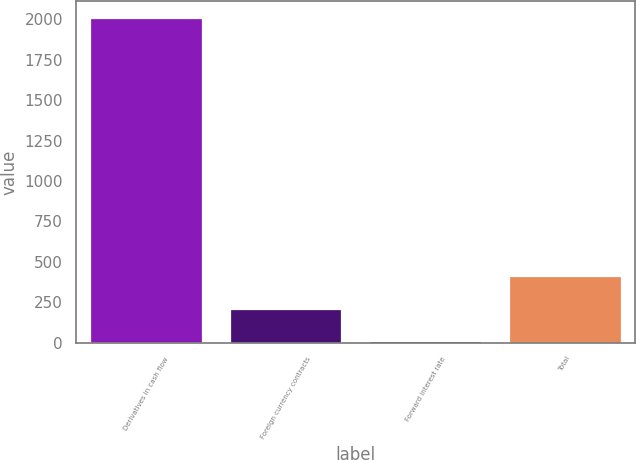Convert chart. <chart><loc_0><loc_0><loc_500><loc_500><bar_chart><fcel>Derivatives in cash flow<fcel>Foreign currency contracts<fcel>Forward interest rate<fcel>Total<nl><fcel>2009<fcel>210.8<fcel>11<fcel>410.6<nl></chart> 